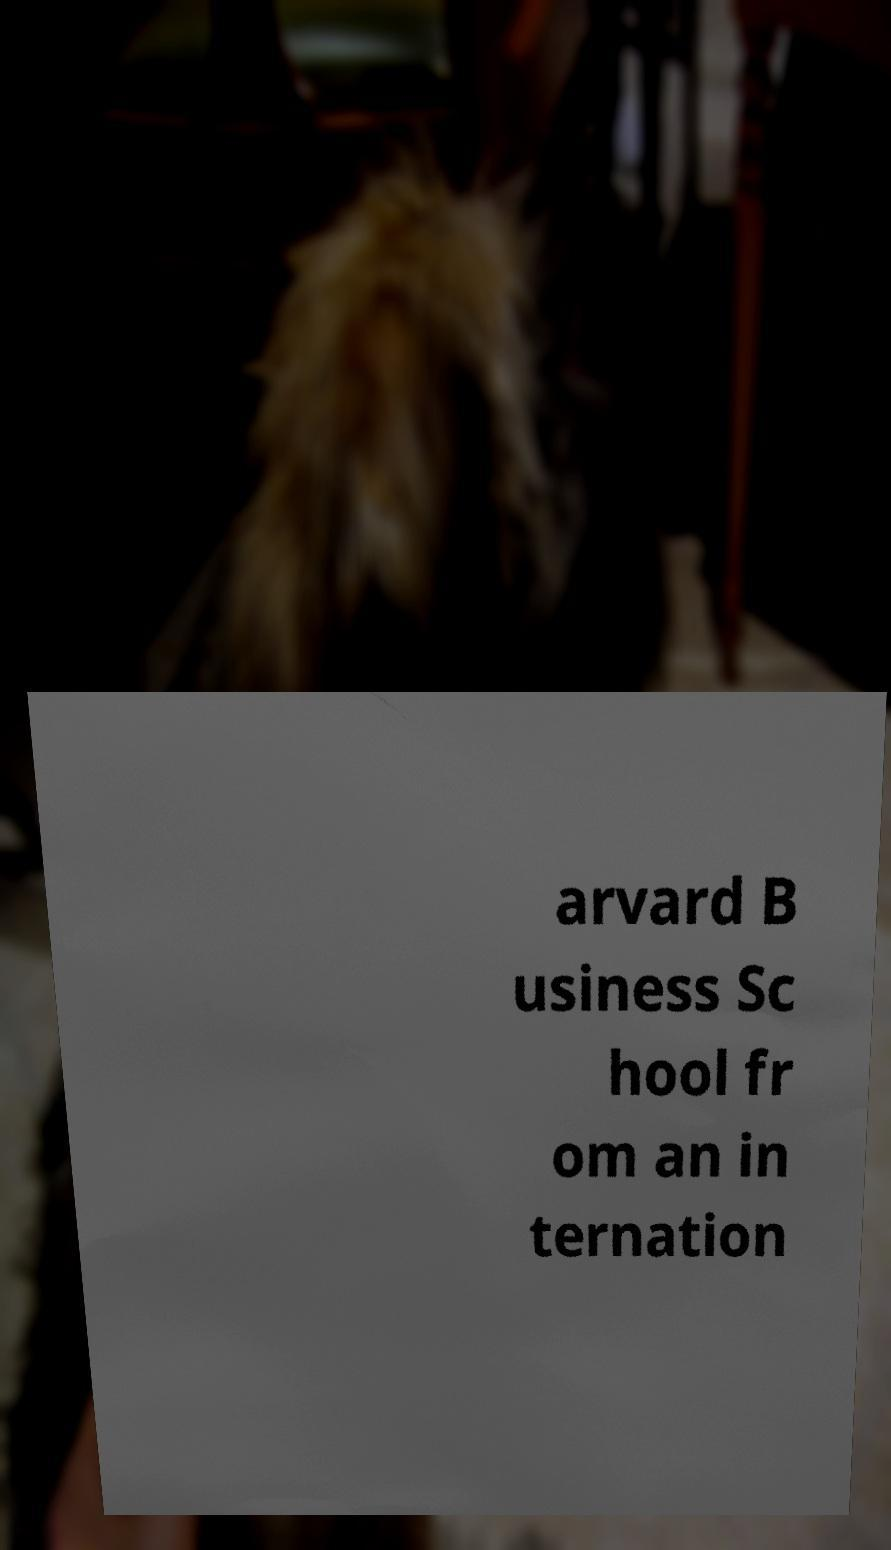Can you accurately transcribe the text from the provided image for me? arvard B usiness Sc hool fr om an in ternation 